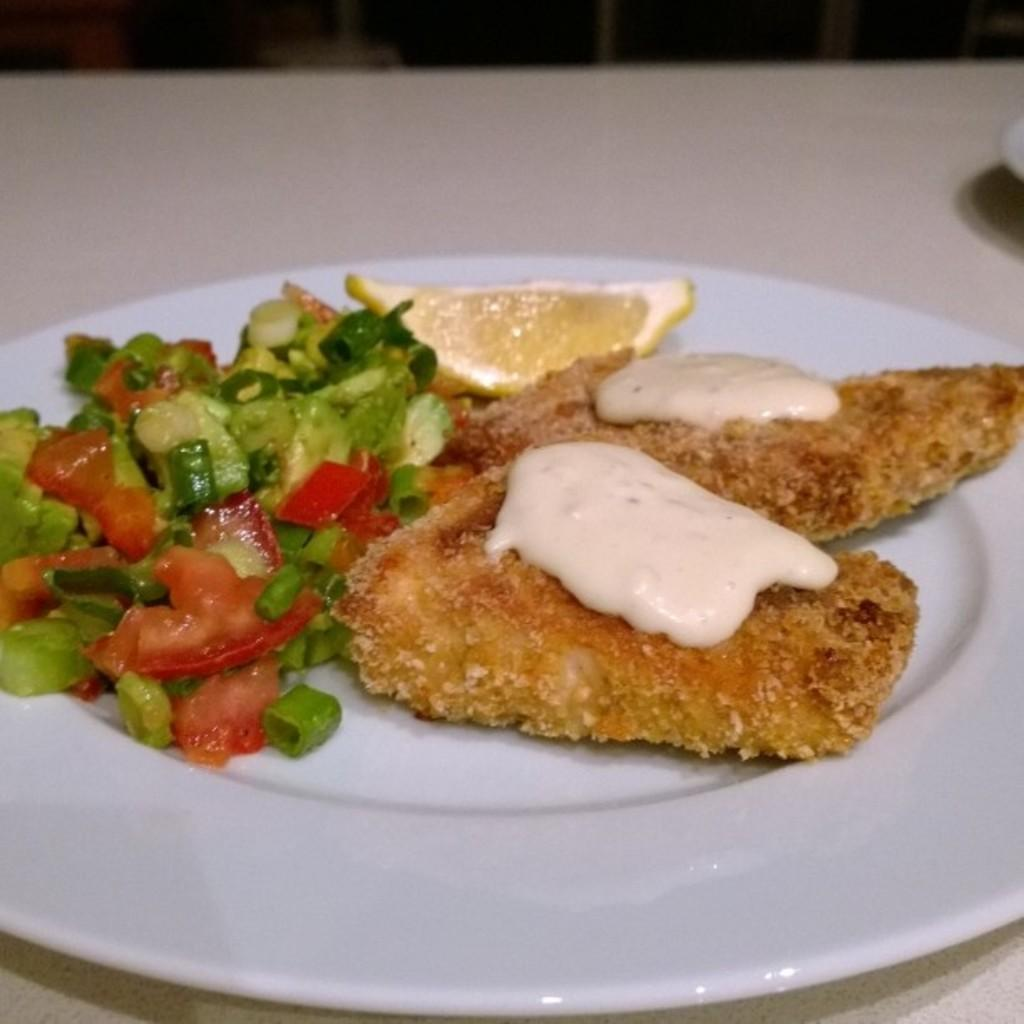What type of food can be seen in the image? The food in the image is in brown, cream, yellow, red, and green colors. How is the food arranged in the image? The food is in a plate. What is the color of the surface on which the plate is placed? The plate is on a white surface. What is the amusement park's name in the image? There is no amusement park or any reference to an amusement park in the image. 